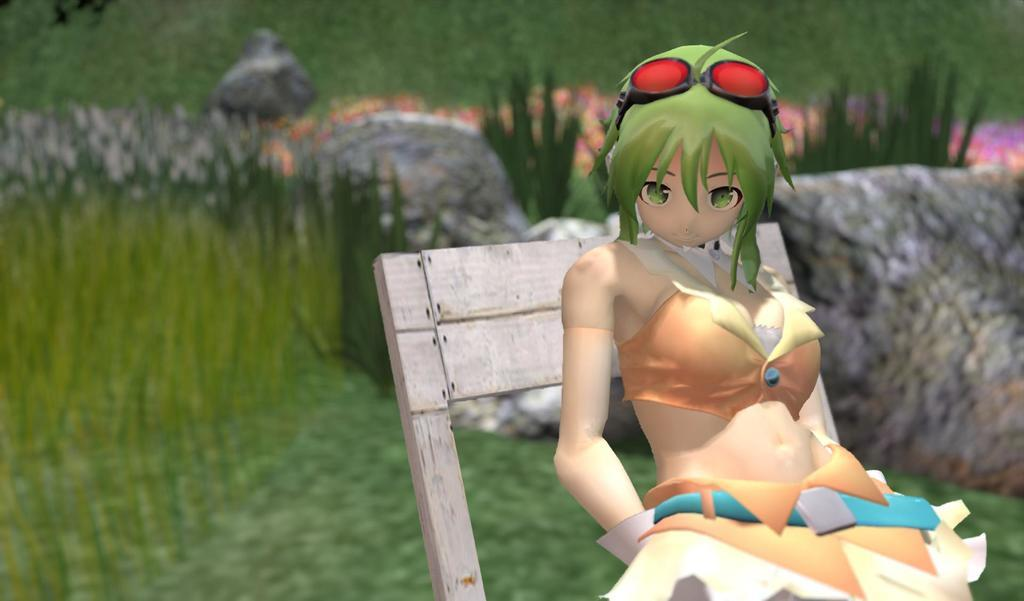What type of image is being described? The image appears to be animated. What is the woman in the image doing? The woman is sitting on a bench in the image. What can be seen in the background of the image? There are rocks, small plants, and grass visible in the background of the image. What material is the bench made of? The bench is made of wood. What type of wax is being used to create the woman's hair in the image? There is no wax present in the image, and the woman's hair is not mentioned as a detail. 